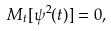<formula> <loc_0><loc_0><loc_500><loc_500>M _ { t } [ \psi ^ { 2 } ( t ) ] = 0 ,</formula> 